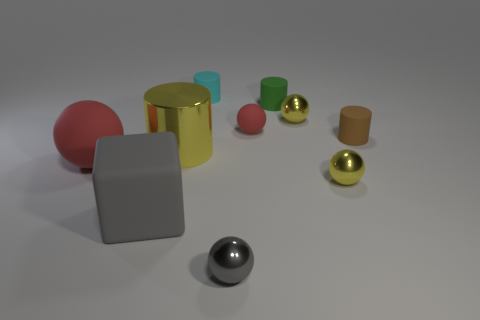There is a small brown matte object that is behind the red thing left of the red rubber thing behind the tiny brown cylinder; what is its shape?
Offer a terse response. Cylinder. How many other things are the same shape as the tiny red rubber thing?
Offer a very short reply. 4. What is the small yellow thing that is behind the tiny rubber cylinder that is in front of the tiny red rubber sphere made of?
Offer a terse response. Metal. Is there anything else that is the same size as the green thing?
Keep it short and to the point. Yes. Is the big cube made of the same material as the sphere to the left of the cyan matte object?
Your response must be concise. Yes. There is a object that is both left of the small cyan thing and on the right side of the big gray rubber thing; what material is it?
Your answer should be very brief. Metal. What color is the rubber cylinder that is in front of the red matte ball behind the large metallic object?
Your answer should be very brief. Brown. There is a yellow object behind the metal cylinder; what is it made of?
Give a very brief answer. Metal. Is the number of brown matte cylinders less than the number of yellow matte blocks?
Provide a short and direct response. No. There is a small brown matte object; is it the same shape as the small yellow shiny object behind the tiny brown object?
Offer a very short reply. No. 